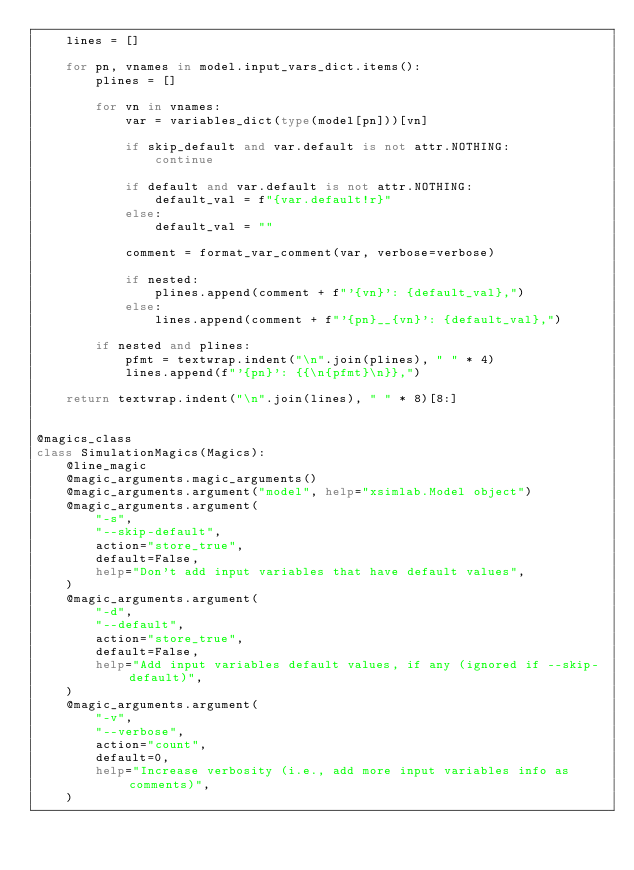<code> <loc_0><loc_0><loc_500><loc_500><_Python_>    lines = []

    for pn, vnames in model.input_vars_dict.items():
        plines = []

        for vn in vnames:
            var = variables_dict(type(model[pn]))[vn]

            if skip_default and var.default is not attr.NOTHING:
                continue

            if default and var.default is not attr.NOTHING:
                default_val = f"{var.default!r}"
            else:
                default_val = ""

            comment = format_var_comment(var, verbose=verbose)

            if nested:
                plines.append(comment + f"'{vn}': {default_val},")
            else:
                lines.append(comment + f"'{pn}__{vn}': {default_val},")

        if nested and plines:
            pfmt = textwrap.indent("\n".join(plines), " " * 4)
            lines.append(f"'{pn}': {{\n{pfmt}\n}},")

    return textwrap.indent("\n".join(lines), " " * 8)[8:]


@magics_class
class SimulationMagics(Magics):
    @line_magic
    @magic_arguments.magic_arguments()
    @magic_arguments.argument("model", help="xsimlab.Model object")
    @magic_arguments.argument(
        "-s",
        "--skip-default",
        action="store_true",
        default=False,
        help="Don't add input variables that have default values",
    )
    @magic_arguments.argument(
        "-d",
        "--default",
        action="store_true",
        default=False,
        help="Add input variables default values, if any (ignored if --skip-default)",
    )
    @magic_arguments.argument(
        "-v",
        "--verbose",
        action="count",
        default=0,
        help="Increase verbosity (i.e., add more input variables info as comments)",
    )</code> 